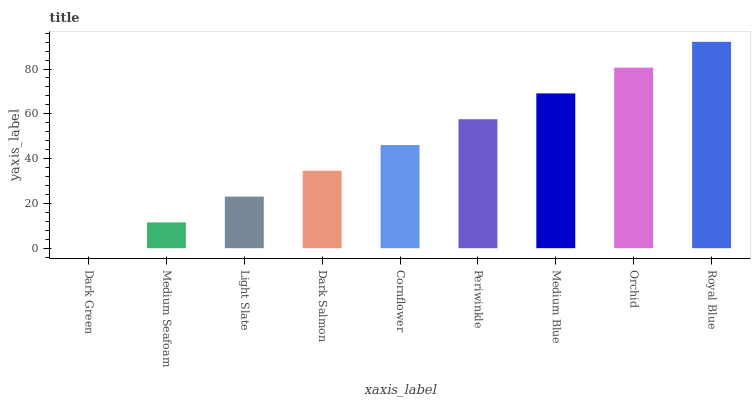Is Dark Green the minimum?
Answer yes or no. Yes. Is Royal Blue the maximum?
Answer yes or no. Yes. Is Medium Seafoam the minimum?
Answer yes or no. No. Is Medium Seafoam the maximum?
Answer yes or no. No. Is Medium Seafoam greater than Dark Green?
Answer yes or no. Yes. Is Dark Green less than Medium Seafoam?
Answer yes or no. Yes. Is Dark Green greater than Medium Seafoam?
Answer yes or no. No. Is Medium Seafoam less than Dark Green?
Answer yes or no. No. Is Cornflower the high median?
Answer yes or no. Yes. Is Cornflower the low median?
Answer yes or no. Yes. Is Medium Seafoam the high median?
Answer yes or no. No. Is Periwinkle the low median?
Answer yes or no. No. 